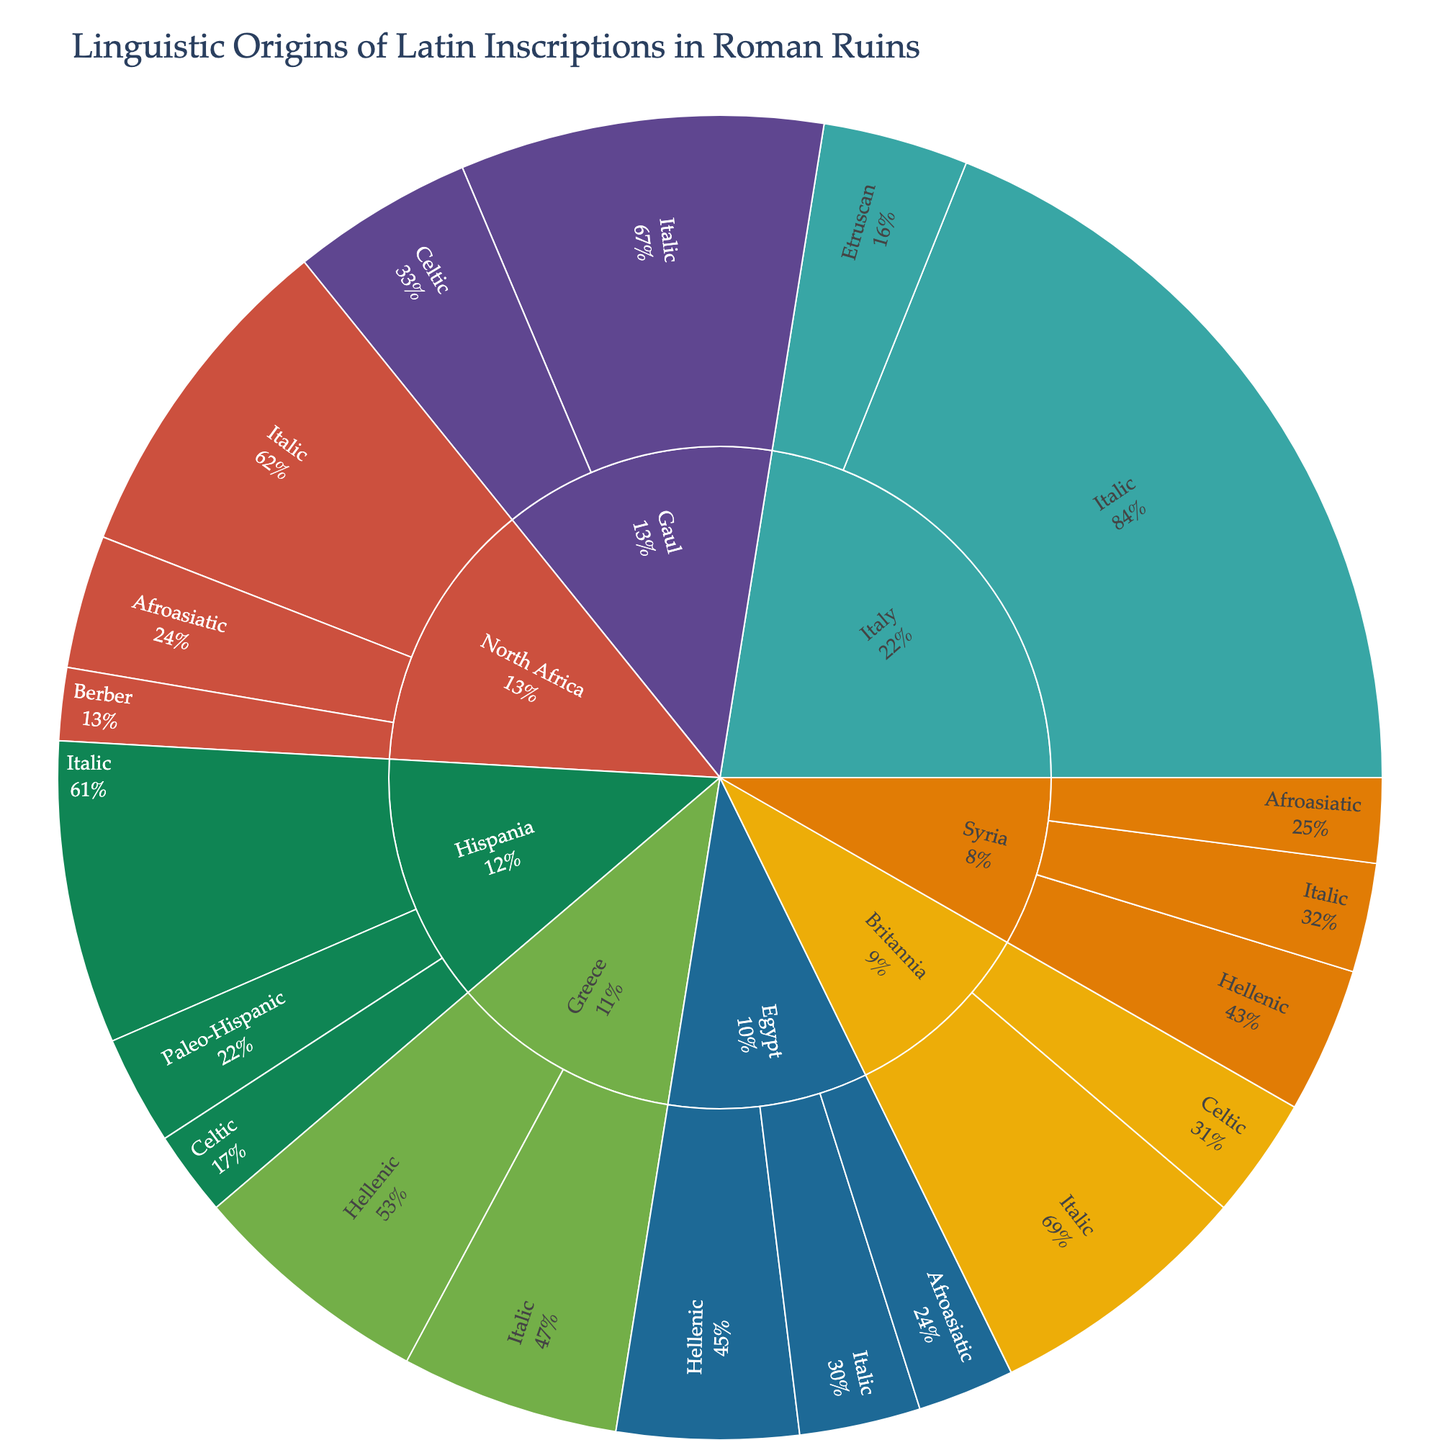Which region has the highest number of Latin inscriptions? Look at the Sunburst plot and identify the segment with the highest count for 'Latin'. North Africa has the highest number (280 inscriptions).
Answer: North Africa What percentage of the inscriptions in Italy are Etruscan? Navigate to the 'Italy' segment and find the 'Italic' and 'Etruscan' segments. The Etruscan section shows its percentage relative to Italy.
Answer: 15.48% Which region has the most diverse language families represented in the inscriptions? Count the number of unique language families in each region. Italy has three (Italic, Etruscan, and Afroasiatic), making it the most diverse.
Answer: Italy How many inscriptions in Gaul are in non-italic languages? Look at the Gaul region and identify segments other than Italic. The only non-italic segment is 'Gaulish' with 150 inscriptions.
Answer: 150 Compare the number of Greek inscriptions in Greece and Egypt. Which one is higher? Check the 'Hellenic' segment under 'Greece' and 'Egypt' and compare their counts, Greece has 200 and Egypt has 150. Greece is higher.
Answer: Greece What is the total number of Latin inscriptions across all regions? Sum the counts of Latin inscriptions across all regions: (500 + 300 + 250 + 180 + 220 + 100 + 90 + 280 = 1920).
Answer: 1920 Which language in Hispania has the least number of inscriptions? Identify the languages in 'Hispania' and compare their counts. 'Celtiberian' with 70 inscriptions is the least.
Answer: Celtiberian What percentage of inscriptions in Egypt are in the Coptic language? Examine the segment for Egypt and find the 'Coptic' section. This shows the percentage of Coptic inscriptions relative to Egypt.
Answer: 15.38% How many Celtic language inscriptions are there in total across all regions? Sum the inscetions of all Celtic languages in Gaul, Hispania, and Britannia. Gaulish (150) + Celtiberian (70) + Brittonic (100) = 320.
Answer: 320 Which region has the lowest number of inscriptions overall? Sum the total number of inscriptions in each region and identify the lowest count. Syria has the lowest with 280 inscriptions.
Answer: Syria 